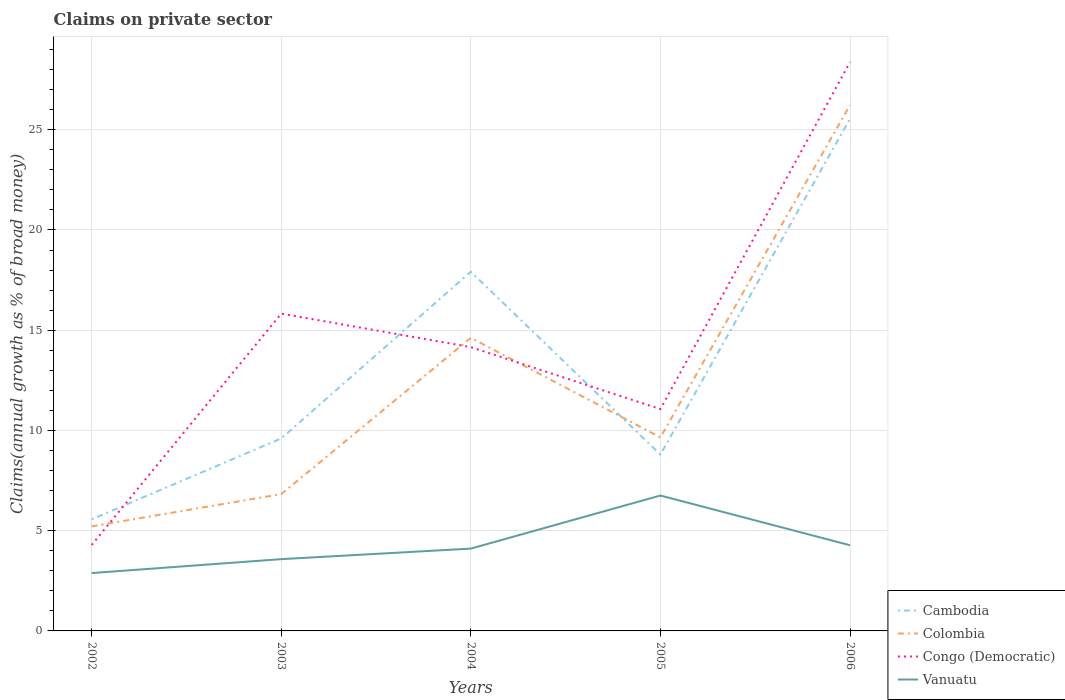How many different coloured lines are there?
Your response must be concise. 4. Does the line corresponding to Congo (Democratic) intersect with the line corresponding to Cambodia?
Ensure brevity in your answer.  Yes. Across all years, what is the maximum percentage of broad money claimed on private sector in Vanuatu?
Provide a short and direct response. 2.89. In which year was the percentage of broad money claimed on private sector in Congo (Democratic) maximum?
Make the answer very short. 2002. What is the total percentage of broad money claimed on private sector in Congo (Democratic) in the graph?
Offer a very short reply. 3.09. What is the difference between the highest and the second highest percentage of broad money claimed on private sector in Cambodia?
Provide a succinct answer. 19.98. What is the difference between the highest and the lowest percentage of broad money claimed on private sector in Vanuatu?
Your answer should be compact. 1. How many lines are there?
Make the answer very short. 4. Does the graph contain grids?
Make the answer very short. Yes. Where does the legend appear in the graph?
Offer a very short reply. Bottom right. What is the title of the graph?
Offer a very short reply. Claims on private sector. What is the label or title of the X-axis?
Ensure brevity in your answer.  Years. What is the label or title of the Y-axis?
Keep it short and to the point. Claims(annual growth as % of broad money). What is the Claims(annual growth as % of broad money) of Cambodia in 2002?
Your answer should be compact. 5.57. What is the Claims(annual growth as % of broad money) of Colombia in 2002?
Your answer should be compact. 5.22. What is the Claims(annual growth as % of broad money) of Congo (Democratic) in 2002?
Ensure brevity in your answer.  4.28. What is the Claims(annual growth as % of broad money) of Vanuatu in 2002?
Keep it short and to the point. 2.89. What is the Claims(annual growth as % of broad money) in Cambodia in 2003?
Ensure brevity in your answer.  9.6. What is the Claims(annual growth as % of broad money) of Colombia in 2003?
Your answer should be compact. 6.82. What is the Claims(annual growth as % of broad money) in Congo (Democratic) in 2003?
Provide a short and direct response. 15.83. What is the Claims(annual growth as % of broad money) in Vanuatu in 2003?
Give a very brief answer. 3.58. What is the Claims(annual growth as % of broad money) of Cambodia in 2004?
Your answer should be very brief. 17.92. What is the Claims(annual growth as % of broad money) in Colombia in 2004?
Your answer should be very brief. 14.62. What is the Claims(annual growth as % of broad money) of Congo (Democratic) in 2004?
Your answer should be compact. 14.16. What is the Claims(annual growth as % of broad money) of Vanuatu in 2004?
Provide a succinct answer. 4.11. What is the Claims(annual growth as % of broad money) of Cambodia in 2005?
Offer a very short reply. 8.8. What is the Claims(annual growth as % of broad money) of Colombia in 2005?
Offer a very short reply. 9.66. What is the Claims(annual growth as % of broad money) in Congo (Democratic) in 2005?
Provide a short and direct response. 11.07. What is the Claims(annual growth as % of broad money) of Vanuatu in 2005?
Make the answer very short. 6.75. What is the Claims(annual growth as % of broad money) in Cambodia in 2006?
Provide a short and direct response. 25.55. What is the Claims(annual growth as % of broad money) of Colombia in 2006?
Give a very brief answer. 26.22. What is the Claims(annual growth as % of broad money) of Congo (Democratic) in 2006?
Your response must be concise. 28.37. What is the Claims(annual growth as % of broad money) of Vanuatu in 2006?
Make the answer very short. 4.27. Across all years, what is the maximum Claims(annual growth as % of broad money) in Cambodia?
Your answer should be compact. 25.55. Across all years, what is the maximum Claims(annual growth as % of broad money) in Colombia?
Keep it short and to the point. 26.22. Across all years, what is the maximum Claims(annual growth as % of broad money) of Congo (Democratic)?
Keep it short and to the point. 28.37. Across all years, what is the maximum Claims(annual growth as % of broad money) of Vanuatu?
Make the answer very short. 6.75. Across all years, what is the minimum Claims(annual growth as % of broad money) in Cambodia?
Provide a succinct answer. 5.57. Across all years, what is the minimum Claims(annual growth as % of broad money) of Colombia?
Your answer should be very brief. 5.22. Across all years, what is the minimum Claims(annual growth as % of broad money) in Congo (Democratic)?
Keep it short and to the point. 4.28. Across all years, what is the minimum Claims(annual growth as % of broad money) of Vanuatu?
Make the answer very short. 2.89. What is the total Claims(annual growth as % of broad money) in Cambodia in the graph?
Ensure brevity in your answer.  67.43. What is the total Claims(annual growth as % of broad money) in Colombia in the graph?
Offer a terse response. 62.54. What is the total Claims(annual growth as % of broad money) of Congo (Democratic) in the graph?
Provide a short and direct response. 73.71. What is the total Claims(annual growth as % of broad money) in Vanuatu in the graph?
Your answer should be very brief. 21.6. What is the difference between the Claims(annual growth as % of broad money) in Cambodia in 2002 and that in 2003?
Provide a succinct answer. -4.04. What is the difference between the Claims(annual growth as % of broad money) of Colombia in 2002 and that in 2003?
Provide a succinct answer. -1.61. What is the difference between the Claims(annual growth as % of broad money) of Congo (Democratic) in 2002 and that in 2003?
Your answer should be compact. -11.54. What is the difference between the Claims(annual growth as % of broad money) of Vanuatu in 2002 and that in 2003?
Give a very brief answer. -0.69. What is the difference between the Claims(annual growth as % of broad money) in Cambodia in 2002 and that in 2004?
Your response must be concise. -12.35. What is the difference between the Claims(annual growth as % of broad money) in Colombia in 2002 and that in 2004?
Your answer should be very brief. -9.4. What is the difference between the Claims(annual growth as % of broad money) in Congo (Democratic) in 2002 and that in 2004?
Give a very brief answer. -9.87. What is the difference between the Claims(annual growth as % of broad money) in Vanuatu in 2002 and that in 2004?
Make the answer very short. -1.22. What is the difference between the Claims(annual growth as % of broad money) in Cambodia in 2002 and that in 2005?
Offer a very short reply. -3.23. What is the difference between the Claims(annual growth as % of broad money) in Colombia in 2002 and that in 2005?
Provide a succinct answer. -4.44. What is the difference between the Claims(annual growth as % of broad money) of Congo (Democratic) in 2002 and that in 2005?
Keep it short and to the point. -6.78. What is the difference between the Claims(annual growth as % of broad money) in Vanuatu in 2002 and that in 2005?
Offer a very short reply. -3.87. What is the difference between the Claims(annual growth as % of broad money) of Cambodia in 2002 and that in 2006?
Your response must be concise. -19.98. What is the difference between the Claims(annual growth as % of broad money) in Colombia in 2002 and that in 2006?
Give a very brief answer. -21.01. What is the difference between the Claims(annual growth as % of broad money) in Congo (Democratic) in 2002 and that in 2006?
Ensure brevity in your answer.  -24.09. What is the difference between the Claims(annual growth as % of broad money) in Vanuatu in 2002 and that in 2006?
Give a very brief answer. -1.39. What is the difference between the Claims(annual growth as % of broad money) of Cambodia in 2003 and that in 2004?
Make the answer very short. -8.32. What is the difference between the Claims(annual growth as % of broad money) in Colombia in 2003 and that in 2004?
Give a very brief answer. -7.8. What is the difference between the Claims(annual growth as % of broad money) in Congo (Democratic) in 2003 and that in 2004?
Give a very brief answer. 1.67. What is the difference between the Claims(annual growth as % of broad money) in Vanuatu in 2003 and that in 2004?
Offer a terse response. -0.53. What is the difference between the Claims(annual growth as % of broad money) in Cambodia in 2003 and that in 2005?
Offer a very short reply. 0.8. What is the difference between the Claims(annual growth as % of broad money) in Colombia in 2003 and that in 2005?
Give a very brief answer. -2.83. What is the difference between the Claims(annual growth as % of broad money) of Congo (Democratic) in 2003 and that in 2005?
Provide a short and direct response. 4.76. What is the difference between the Claims(annual growth as % of broad money) of Vanuatu in 2003 and that in 2005?
Your response must be concise. -3.17. What is the difference between the Claims(annual growth as % of broad money) of Cambodia in 2003 and that in 2006?
Offer a very short reply. -15.95. What is the difference between the Claims(annual growth as % of broad money) in Colombia in 2003 and that in 2006?
Offer a very short reply. -19.4. What is the difference between the Claims(annual growth as % of broad money) in Congo (Democratic) in 2003 and that in 2006?
Your answer should be very brief. -12.55. What is the difference between the Claims(annual growth as % of broad money) of Vanuatu in 2003 and that in 2006?
Your answer should be very brief. -0.69. What is the difference between the Claims(annual growth as % of broad money) in Cambodia in 2004 and that in 2005?
Your answer should be very brief. 9.12. What is the difference between the Claims(annual growth as % of broad money) in Colombia in 2004 and that in 2005?
Make the answer very short. 4.97. What is the difference between the Claims(annual growth as % of broad money) of Congo (Democratic) in 2004 and that in 2005?
Offer a terse response. 3.09. What is the difference between the Claims(annual growth as % of broad money) of Vanuatu in 2004 and that in 2005?
Make the answer very short. -2.65. What is the difference between the Claims(annual growth as % of broad money) of Cambodia in 2004 and that in 2006?
Provide a short and direct response. -7.63. What is the difference between the Claims(annual growth as % of broad money) in Colombia in 2004 and that in 2006?
Your answer should be compact. -11.6. What is the difference between the Claims(annual growth as % of broad money) in Congo (Democratic) in 2004 and that in 2006?
Keep it short and to the point. -14.22. What is the difference between the Claims(annual growth as % of broad money) of Vanuatu in 2004 and that in 2006?
Provide a succinct answer. -0.17. What is the difference between the Claims(annual growth as % of broad money) in Cambodia in 2005 and that in 2006?
Provide a succinct answer. -16.75. What is the difference between the Claims(annual growth as % of broad money) of Colombia in 2005 and that in 2006?
Keep it short and to the point. -16.57. What is the difference between the Claims(annual growth as % of broad money) in Congo (Democratic) in 2005 and that in 2006?
Make the answer very short. -17.31. What is the difference between the Claims(annual growth as % of broad money) of Vanuatu in 2005 and that in 2006?
Offer a very short reply. 2.48. What is the difference between the Claims(annual growth as % of broad money) in Cambodia in 2002 and the Claims(annual growth as % of broad money) in Colombia in 2003?
Provide a short and direct response. -1.26. What is the difference between the Claims(annual growth as % of broad money) of Cambodia in 2002 and the Claims(annual growth as % of broad money) of Congo (Democratic) in 2003?
Give a very brief answer. -10.26. What is the difference between the Claims(annual growth as % of broad money) in Cambodia in 2002 and the Claims(annual growth as % of broad money) in Vanuatu in 2003?
Your response must be concise. 1.99. What is the difference between the Claims(annual growth as % of broad money) in Colombia in 2002 and the Claims(annual growth as % of broad money) in Congo (Democratic) in 2003?
Your response must be concise. -10.61. What is the difference between the Claims(annual growth as % of broad money) in Colombia in 2002 and the Claims(annual growth as % of broad money) in Vanuatu in 2003?
Your response must be concise. 1.64. What is the difference between the Claims(annual growth as % of broad money) of Congo (Democratic) in 2002 and the Claims(annual growth as % of broad money) of Vanuatu in 2003?
Offer a very short reply. 0.7. What is the difference between the Claims(annual growth as % of broad money) in Cambodia in 2002 and the Claims(annual growth as % of broad money) in Colombia in 2004?
Offer a terse response. -9.05. What is the difference between the Claims(annual growth as % of broad money) in Cambodia in 2002 and the Claims(annual growth as % of broad money) in Congo (Democratic) in 2004?
Your answer should be very brief. -8.59. What is the difference between the Claims(annual growth as % of broad money) of Cambodia in 2002 and the Claims(annual growth as % of broad money) of Vanuatu in 2004?
Offer a terse response. 1.46. What is the difference between the Claims(annual growth as % of broad money) of Colombia in 2002 and the Claims(annual growth as % of broad money) of Congo (Democratic) in 2004?
Your answer should be compact. -8.94. What is the difference between the Claims(annual growth as % of broad money) in Colombia in 2002 and the Claims(annual growth as % of broad money) in Vanuatu in 2004?
Make the answer very short. 1.11. What is the difference between the Claims(annual growth as % of broad money) of Congo (Democratic) in 2002 and the Claims(annual growth as % of broad money) of Vanuatu in 2004?
Your answer should be very brief. 0.18. What is the difference between the Claims(annual growth as % of broad money) in Cambodia in 2002 and the Claims(annual growth as % of broad money) in Colombia in 2005?
Provide a short and direct response. -4.09. What is the difference between the Claims(annual growth as % of broad money) in Cambodia in 2002 and the Claims(annual growth as % of broad money) in Congo (Democratic) in 2005?
Provide a short and direct response. -5.5. What is the difference between the Claims(annual growth as % of broad money) in Cambodia in 2002 and the Claims(annual growth as % of broad money) in Vanuatu in 2005?
Your answer should be compact. -1.19. What is the difference between the Claims(annual growth as % of broad money) of Colombia in 2002 and the Claims(annual growth as % of broad money) of Congo (Democratic) in 2005?
Provide a short and direct response. -5.85. What is the difference between the Claims(annual growth as % of broad money) of Colombia in 2002 and the Claims(annual growth as % of broad money) of Vanuatu in 2005?
Give a very brief answer. -1.54. What is the difference between the Claims(annual growth as % of broad money) in Congo (Democratic) in 2002 and the Claims(annual growth as % of broad money) in Vanuatu in 2005?
Your answer should be very brief. -2.47. What is the difference between the Claims(annual growth as % of broad money) of Cambodia in 2002 and the Claims(annual growth as % of broad money) of Colombia in 2006?
Your response must be concise. -20.66. What is the difference between the Claims(annual growth as % of broad money) of Cambodia in 2002 and the Claims(annual growth as % of broad money) of Congo (Democratic) in 2006?
Your answer should be very brief. -22.81. What is the difference between the Claims(annual growth as % of broad money) of Cambodia in 2002 and the Claims(annual growth as % of broad money) of Vanuatu in 2006?
Offer a terse response. 1.29. What is the difference between the Claims(annual growth as % of broad money) of Colombia in 2002 and the Claims(annual growth as % of broad money) of Congo (Democratic) in 2006?
Keep it short and to the point. -23.16. What is the difference between the Claims(annual growth as % of broad money) in Colombia in 2002 and the Claims(annual growth as % of broad money) in Vanuatu in 2006?
Keep it short and to the point. 0.94. What is the difference between the Claims(annual growth as % of broad money) in Congo (Democratic) in 2002 and the Claims(annual growth as % of broad money) in Vanuatu in 2006?
Keep it short and to the point. 0.01. What is the difference between the Claims(annual growth as % of broad money) in Cambodia in 2003 and the Claims(annual growth as % of broad money) in Colombia in 2004?
Your answer should be compact. -5.02. What is the difference between the Claims(annual growth as % of broad money) in Cambodia in 2003 and the Claims(annual growth as % of broad money) in Congo (Democratic) in 2004?
Make the answer very short. -4.55. What is the difference between the Claims(annual growth as % of broad money) of Cambodia in 2003 and the Claims(annual growth as % of broad money) of Vanuatu in 2004?
Give a very brief answer. 5.5. What is the difference between the Claims(annual growth as % of broad money) in Colombia in 2003 and the Claims(annual growth as % of broad money) in Congo (Democratic) in 2004?
Your response must be concise. -7.33. What is the difference between the Claims(annual growth as % of broad money) in Colombia in 2003 and the Claims(annual growth as % of broad money) in Vanuatu in 2004?
Provide a succinct answer. 2.72. What is the difference between the Claims(annual growth as % of broad money) in Congo (Democratic) in 2003 and the Claims(annual growth as % of broad money) in Vanuatu in 2004?
Make the answer very short. 11.72. What is the difference between the Claims(annual growth as % of broad money) in Cambodia in 2003 and the Claims(annual growth as % of broad money) in Colombia in 2005?
Make the answer very short. -0.05. What is the difference between the Claims(annual growth as % of broad money) in Cambodia in 2003 and the Claims(annual growth as % of broad money) in Congo (Democratic) in 2005?
Ensure brevity in your answer.  -1.46. What is the difference between the Claims(annual growth as % of broad money) of Cambodia in 2003 and the Claims(annual growth as % of broad money) of Vanuatu in 2005?
Ensure brevity in your answer.  2.85. What is the difference between the Claims(annual growth as % of broad money) of Colombia in 2003 and the Claims(annual growth as % of broad money) of Congo (Democratic) in 2005?
Provide a succinct answer. -4.24. What is the difference between the Claims(annual growth as % of broad money) in Colombia in 2003 and the Claims(annual growth as % of broad money) in Vanuatu in 2005?
Offer a terse response. 0.07. What is the difference between the Claims(annual growth as % of broad money) in Congo (Democratic) in 2003 and the Claims(annual growth as % of broad money) in Vanuatu in 2005?
Offer a terse response. 9.07. What is the difference between the Claims(annual growth as % of broad money) in Cambodia in 2003 and the Claims(annual growth as % of broad money) in Colombia in 2006?
Provide a succinct answer. -16.62. What is the difference between the Claims(annual growth as % of broad money) of Cambodia in 2003 and the Claims(annual growth as % of broad money) of Congo (Democratic) in 2006?
Your answer should be very brief. -18.77. What is the difference between the Claims(annual growth as % of broad money) of Cambodia in 2003 and the Claims(annual growth as % of broad money) of Vanuatu in 2006?
Provide a short and direct response. 5.33. What is the difference between the Claims(annual growth as % of broad money) of Colombia in 2003 and the Claims(annual growth as % of broad money) of Congo (Democratic) in 2006?
Provide a short and direct response. -21.55. What is the difference between the Claims(annual growth as % of broad money) of Colombia in 2003 and the Claims(annual growth as % of broad money) of Vanuatu in 2006?
Provide a succinct answer. 2.55. What is the difference between the Claims(annual growth as % of broad money) in Congo (Democratic) in 2003 and the Claims(annual growth as % of broad money) in Vanuatu in 2006?
Provide a succinct answer. 11.55. What is the difference between the Claims(annual growth as % of broad money) of Cambodia in 2004 and the Claims(annual growth as % of broad money) of Colombia in 2005?
Make the answer very short. 8.26. What is the difference between the Claims(annual growth as % of broad money) of Cambodia in 2004 and the Claims(annual growth as % of broad money) of Congo (Democratic) in 2005?
Your answer should be compact. 6.85. What is the difference between the Claims(annual growth as % of broad money) in Cambodia in 2004 and the Claims(annual growth as % of broad money) in Vanuatu in 2005?
Your answer should be compact. 11.16. What is the difference between the Claims(annual growth as % of broad money) in Colombia in 2004 and the Claims(annual growth as % of broad money) in Congo (Democratic) in 2005?
Make the answer very short. 3.55. What is the difference between the Claims(annual growth as % of broad money) in Colombia in 2004 and the Claims(annual growth as % of broad money) in Vanuatu in 2005?
Give a very brief answer. 7.87. What is the difference between the Claims(annual growth as % of broad money) in Congo (Democratic) in 2004 and the Claims(annual growth as % of broad money) in Vanuatu in 2005?
Provide a succinct answer. 7.4. What is the difference between the Claims(annual growth as % of broad money) of Cambodia in 2004 and the Claims(annual growth as % of broad money) of Colombia in 2006?
Offer a very short reply. -8.31. What is the difference between the Claims(annual growth as % of broad money) in Cambodia in 2004 and the Claims(annual growth as % of broad money) in Congo (Democratic) in 2006?
Your answer should be very brief. -10.46. What is the difference between the Claims(annual growth as % of broad money) in Cambodia in 2004 and the Claims(annual growth as % of broad money) in Vanuatu in 2006?
Offer a terse response. 13.64. What is the difference between the Claims(annual growth as % of broad money) in Colombia in 2004 and the Claims(annual growth as % of broad money) in Congo (Democratic) in 2006?
Provide a short and direct response. -13.75. What is the difference between the Claims(annual growth as % of broad money) in Colombia in 2004 and the Claims(annual growth as % of broad money) in Vanuatu in 2006?
Give a very brief answer. 10.35. What is the difference between the Claims(annual growth as % of broad money) in Congo (Democratic) in 2004 and the Claims(annual growth as % of broad money) in Vanuatu in 2006?
Keep it short and to the point. 9.88. What is the difference between the Claims(annual growth as % of broad money) of Cambodia in 2005 and the Claims(annual growth as % of broad money) of Colombia in 2006?
Your answer should be compact. -17.43. What is the difference between the Claims(annual growth as % of broad money) of Cambodia in 2005 and the Claims(annual growth as % of broad money) of Congo (Democratic) in 2006?
Make the answer very short. -19.58. What is the difference between the Claims(annual growth as % of broad money) in Cambodia in 2005 and the Claims(annual growth as % of broad money) in Vanuatu in 2006?
Give a very brief answer. 4.52. What is the difference between the Claims(annual growth as % of broad money) of Colombia in 2005 and the Claims(annual growth as % of broad money) of Congo (Democratic) in 2006?
Your response must be concise. -18.72. What is the difference between the Claims(annual growth as % of broad money) of Colombia in 2005 and the Claims(annual growth as % of broad money) of Vanuatu in 2006?
Your answer should be very brief. 5.38. What is the difference between the Claims(annual growth as % of broad money) of Congo (Democratic) in 2005 and the Claims(annual growth as % of broad money) of Vanuatu in 2006?
Make the answer very short. 6.79. What is the average Claims(annual growth as % of broad money) of Cambodia per year?
Offer a terse response. 13.49. What is the average Claims(annual growth as % of broad money) in Colombia per year?
Provide a short and direct response. 12.51. What is the average Claims(annual growth as % of broad money) in Congo (Democratic) per year?
Keep it short and to the point. 14.74. What is the average Claims(annual growth as % of broad money) of Vanuatu per year?
Your answer should be very brief. 4.32. In the year 2002, what is the difference between the Claims(annual growth as % of broad money) of Cambodia and Claims(annual growth as % of broad money) of Colombia?
Your answer should be very brief. 0.35. In the year 2002, what is the difference between the Claims(annual growth as % of broad money) of Cambodia and Claims(annual growth as % of broad money) of Congo (Democratic)?
Your answer should be compact. 1.28. In the year 2002, what is the difference between the Claims(annual growth as % of broad money) in Cambodia and Claims(annual growth as % of broad money) in Vanuatu?
Provide a short and direct response. 2.68. In the year 2002, what is the difference between the Claims(annual growth as % of broad money) in Colombia and Claims(annual growth as % of broad money) in Congo (Democratic)?
Make the answer very short. 0.93. In the year 2002, what is the difference between the Claims(annual growth as % of broad money) in Colombia and Claims(annual growth as % of broad money) in Vanuatu?
Offer a very short reply. 2.33. In the year 2002, what is the difference between the Claims(annual growth as % of broad money) in Congo (Democratic) and Claims(annual growth as % of broad money) in Vanuatu?
Make the answer very short. 1.4. In the year 2003, what is the difference between the Claims(annual growth as % of broad money) of Cambodia and Claims(annual growth as % of broad money) of Colombia?
Ensure brevity in your answer.  2.78. In the year 2003, what is the difference between the Claims(annual growth as % of broad money) of Cambodia and Claims(annual growth as % of broad money) of Congo (Democratic)?
Your answer should be very brief. -6.23. In the year 2003, what is the difference between the Claims(annual growth as % of broad money) in Cambodia and Claims(annual growth as % of broad money) in Vanuatu?
Offer a very short reply. 6.02. In the year 2003, what is the difference between the Claims(annual growth as % of broad money) in Colombia and Claims(annual growth as % of broad money) in Congo (Democratic)?
Your response must be concise. -9. In the year 2003, what is the difference between the Claims(annual growth as % of broad money) in Colombia and Claims(annual growth as % of broad money) in Vanuatu?
Ensure brevity in your answer.  3.24. In the year 2003, what is the difference between the Claims(annual growth as % of broad money) in Congo (Democratic) and Claims(annual growth as % of broad money) in Vanuatu?
Offer a very short reply. 12.25. In the year 2004, what is the difference between the Claims(annual growth as % of broad money) in Cambodia and Claims(annual growth as % of broad money) in Colombia?
Give a very brief answer. 3.3. In the year 2004, what is the difference between the Claims(annual growth as % of broad money) in Cambodia and Claims(annual growth as % of broad money) in Congo (Democratic)?
Your answer should be very brief. 3.76. In the year 2004, what is the difference between the Claims(annual growth as % of broad money) in Cambodia and Claims(annual growth as % of broad money) in Vanuatu?
Your answer should be compact. 13.81. In the year 2004, what is the difference between the Claims(annual growth as % of broad money) of Colombia and Claims(annual growth as % of broad money) of Congo (Democratic)?
Keep it short and to the point. 0.46. In the year 2004, what is the difference between the Claims(annual growth as % of broad money) of Colombia and Claims(annual growth as % of broad money) of Vanuatu?
Provide a short and direct response. 10.51. In the year 2004, what is the difference between the Claims(annual growth as % of broad money) of Congo (Democratic) and Claims(annual growth as % of broad money) of Vanuatu?
Offer a very short reply. 10.05. In the year 2005, what is the difference between the Claims(annual growth as % of broad money) in Cambodia and Claims(annual growth as % of broad money) in Colombia?
Provide a succinct answer. -0.86. In the year 2005, what is the difference between the Claims(annual growth as % of broad money) in Cambodia and Claims(annual growth as % of broad money) in Congo (Democratic)?
Your answer should be compact. -2.27. In the year 2005, what is the difference between the Claims(annual growth as % of broad money) of Cambodia and Claims(annual growth as % of broad money) of Vanuatu?
Offer a terse response. 2.04. In the year 2005, what is the difference between the Claims(annual growth as % of broad money) in Colombia and Claims(annual growth as % of broad money) in Congo (Democratic)?
Provide a short and direct response. -1.41. In the year 2005, what is the difference between the Claims(annual growth as % of broad money) of Colombia and Claims(annual growth as % of broad money) of Vanuatu?
Make the answer very short. 2.9. In the year 2005, what is the difference between the Claims(annual growth as % of broad money) in Congo (Democratic) and Claims(annual growth as % of broad money) in Vanuatu?
Keep it short and to the point. 4.31. In the year 2006, what is the difference between the Claims(annual growth as % of broad money) in Cambodia and Claims(annual growth as % of broad money) in Colombia?
Your response must be concise. -0.68. In the year 2006, what is the difference between the Claims(annual growth as % of broad money) in Cambodia and Claims(annual growth as % of broad money) in Congo (Democratic)?
Your answer should be compact. -2.82. In the year 2006, what is the difference between the Claims(annual growth as % of broad money) in Cambodia and Claims(annual growth as % of broad money) in Vanuatu?
Provide a succinct answer. 21.28. In the year 2006, what is the difference between the Claims(annual growth as % of broad money) of Colombia and Claims(annual growth as % of broad money) of Congo (Democratic)?
Give a very brief answer. -2.15. In the year 2006, what is the difference between the Claims(annual growth as % of broad money) of Colombia and Claims(annual growth as % of broad money) of Vanuatu?
Offer a very short reply. 21.95. In the year 2006, what is the difference between the Claims(annual growth as % of broad money) in Congo (Democratic) and Claims(annual growth as % of broad money) in Vanuatu?
Your answer should be very brief. 24.1. What is the ratio of the Claims(annual growth as % of broad money) in Cambodia in 2002 to that in 2003?
Provide a succinct answer. 0.58. What is the ratio of the Claims(annual growth as % of broad money) of Colombia in 2002 to that in 2003?
Your answer should be compact. 0.76. What is the ratio of the Claims(annual growth as % of broad money) in Congo (Democratic) in 2002 to that in 2003?
Keep it short and to the point. 0.27. What is the ratio of the Claims(annual growth as % of broad money) of Vanuatu in 2002 to that in 2003?
Your answer should be very brief. 0.81. What is the ratio of the Claims(annual growth as % of broad money) in Cambodia in 2002 to that in 2004?
Keep it short and to the point. 0.31. What is the ratio of the Claims(annual growth as % of broad money) of Colombia in 2002 to that in 2004?
Your answer should be very brief. 0.36. What is the ratio of the Claims(annual growth as % of broad money) in Congo (Democratic) in 2002 to that in 2004?
Offer a terse response. 0.3. What is the ratio of the Claims(annual growth as % of broad money) in Vanuatu in 2002 to that in 2004?
Offer a terse response. 0.7. What is the ratio of the Claims(annual growth as % of broad money) of Cambodia in 2002 to that in 2005?
Your answer should be very brief. 0.63. What is the ratio of the Claims(annual growth as % of broad money) of Colombia in 2002 to that in 2005?
Make the answer very short. 0.54. What is the ratio of the Claims(annual growth as % of broad money) of Congo (Democratic) in 2002 to that in 2005?
Offer a very short reply. 0.39. What is the ratio of the Claims(annual growth as % of broad money) of Vanuatu in 2002 to that in 2005?
Provide a succinct answer. 0.43. What is the ratio of the Claims(annual growth as % of broad money) in Cambodia in 2002 to that in 2006?
Your answer should be compact. 0.22. What is the ratio of the Claims(annual growth as % of broad money) in Colombia in 2002 to that in 2006?
Give a very brief answer. 0.2. What is the ratio of the Claims(annual growth as % of broad money) in Congo (Democratic) in 2002 to that in 2006?
Make the answer very short. 0.15. What is the ratio of the Claims(annual growth as % of broad money) of Vanuatu in 2002 to that in 2006?
Offer a terse response. 0.68. What is the ratio of the Claims(annual growth as % of broad money) of Cambodia in 2003 to that in 2004?
Provide a short and direct response. 0.54. What is the ratio of the Claims(annual growth as % of broad money) of Colombia in 2003 to that in 2004?
Provide a short and direct response. 0.47. What is the ratio of the Claims(annual growth as % of broad money) of Congo (Democratic) in 2003 to that in 2004?
Your answer should be very brief. 1.12. What is the ratio of the Claims(annual growth as % of broad money) in Vanuatu in 2003 to that in 2004?
Offer a terse response. 0.87. What is the ratio of the Claims(annual growth as % of broad money) in Cambodia in 2003 to that in 2005?
Your answer should be compact. 1.09. What is the ratio of the Claims(annual growth as % of broad money) in Colombia in 2003 to that in 2005?
Offer a terse response. 0.71. What is the ratio of the Claims(annual growth as % of broad money) in Congo (Democratic) in 2003 to that in 2005?
Keep it short and to the point. 1.43. What is the ratio of the Claims(annual growth as % of broad money) in Vanuatu in 2003 to that in 2005?
Keep it short and to the point. 0.53. What is the ratio of the Claims(annual growth as % of broad money) of Cambodia in 2003 to that in 2006?
Keep it short and to the point. 0.38. What is the ratio of the Claims(annual growth as % of broad money) in Colombia in 2003 to that in 2006?
Provide a short and direct response. 0.26. What is the ratio of the Claims(annual growth as % of broad money) of Congo (Democratic) in 2003 to that in 2006?
Offer a terse response. 0.56. What is the ratio of the Claims(annual growth as % of broad money) in Vanuatu in 2003 to that in 2006?
Ensure brevity in your answer.  0.84. What is the ratio of the Claims(annual growth as % of broad money) of Cambodia in 2004 to that in 2005?
Your response must be concise. 2.04. What is the ratio of the Claims(annual growth as % of broad money) in Colombia in 2004 to that in 2005?
Offer a very short reply. 1.51. What is the ratio of the Claims(annual growth as % of broad money) in Congo (Democratic) in 2004 to that in 2005?
Your answer should be very brief. 1.28. What is the ratio of the Claims(annual growth as % of broad money) in Vanuatu in 2004 to that in 2005?
Provide a short and direct response. 0.61. What is the ratio of the Claims(annual growth as % of broad money) of Cambodia in 2004 to that in 2006?
Your answer should be compact. 0.7. What is the ratio of the Claims(annual growth as % of broad money) in Colombia in 2004 to that in 2006?
Give a very brief answer. 0.56. What is the ratio of the Claims(annual growth as % of broad money) of Congo (Democratic) in 2004 to that in 2006?
Give a very brief answer. 0.5. What is the ratio of the Claims(annual growth as % of broad money) of Vanuatu in 2004 to that in 2006?
Make the answer very short. 0.96. What is the ratio of the Claims(annual growth as % of broad money) in Cambodia in 2005 to that in 2006?
Your answer should be very brief. 0.34. What is the ratio of the Claims(annual growth as % of broad money) of Colombia in 2005 to that in 2006?
Offer a terse response. 0.37. What is the ratio of the Claims(annual growth as % of broad money) of Congo (Democratic) in 2005 to that in 2006?
Give a very brief answer. 0.39. What is the ratio of the Claims(annual growth as % of broad money) in Vanuatu in 2005 to that in 2006?
Offer a terse response. 1.58. What is the difference between the highest and the second highest Claims(annual growth as % of broad money) of Cambodia?
Your answer should be very brief. 7.63. What is the difference between the highest and the second highest Claims(annual growth as % of broad money) in Colombia?
Ensure brevity in your answer.  11.6. What is the difference between the highest and the second highest Claims(annual growth as % of broad money) of Congo (Democratic)?
Make the answer very short. 12.55. What is the difference between the highest and the second highest Claims(annual growth as % of broad money) in Vanuatu?
Offer a terse response. 2.48. What is the difference between the highest and the lowest Claims(annual growth as % of broad money) of Cambodia?
Keep it short and to the point. 19.98. What is the difference between the highest and the lowest Claims(annual growth as % of broad money) in Colombia?
Keep it short and to the point. 21.01. What is the difference between the highest and the lowest Claims(annual growth as % of broad money) of Congo (Democratic)?
Give a very brief answer. 24.09. What is the difference between the highest and the lowest Claims(annual growth as % of broad money) in Vanuatu?
Offer a very short reply. 3.87. 